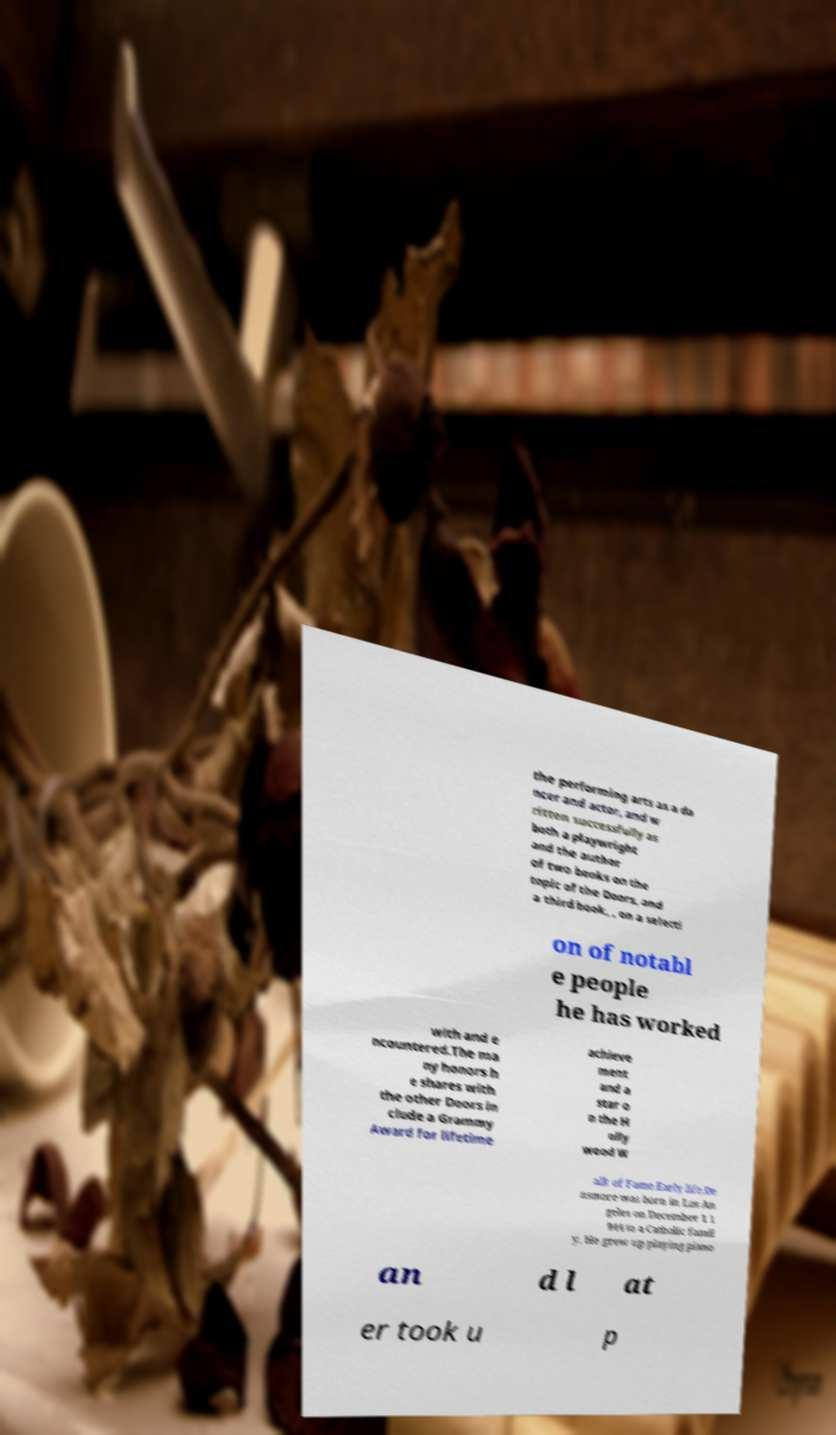There's text embedded in this image that I need extracted. Can you transcribe it verbatim? the performing arts as a da ncer and actor, and w ritten successfully as both a playwright and the author of two books on the topic of the Doors, and a third book, , on a selecti on of notabl e people he has worked with and e ncountered.The ma ny honors h e shares with the other Doors in clude a Grammy Award for lifetime achieve ment and a star o n the H olly wood W alk of Fame.Early life.De nsmore was born in Los An geles on December 1 1 944 to a Catholic famil y. He grew up playing piano an d l at er took u p 